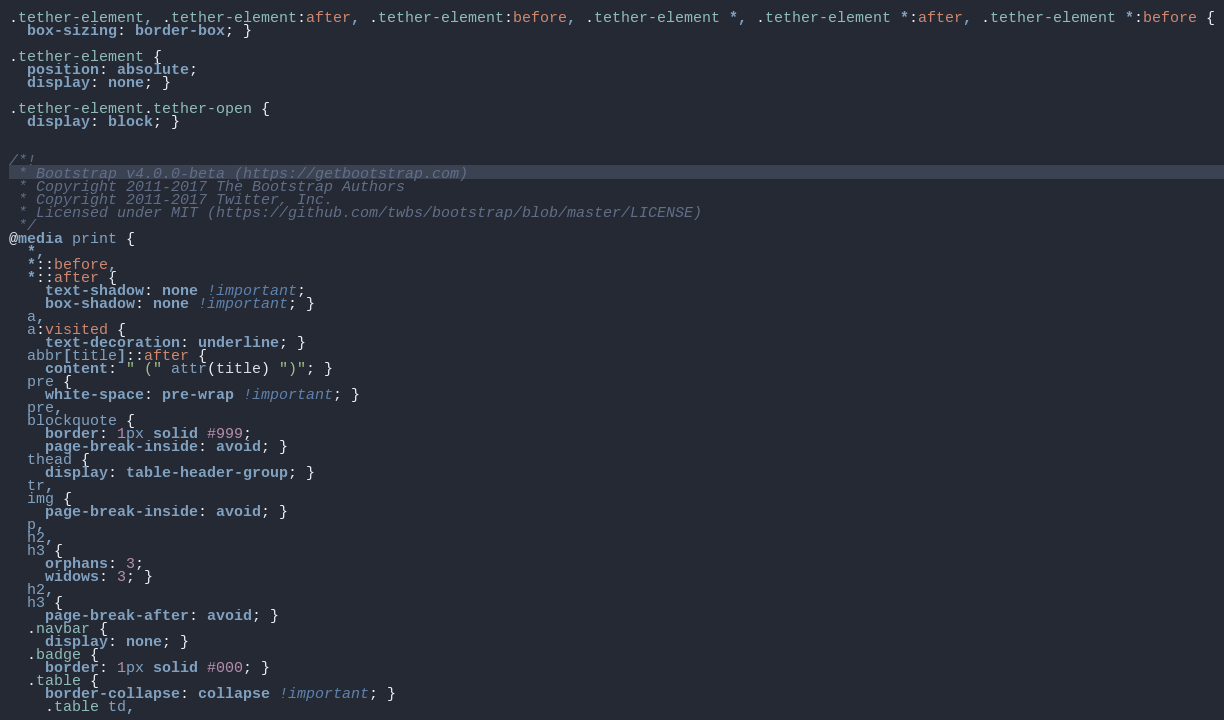<code> <loc_0><loc_0><loc_500><loc_500><_CSS_>.tether-element, .tether-element:after, .tether-element:before, .tether-element *, .tether-element *:after, .tether-element *:before {
  box-sizing: border-box; }

.tether-element {
  position: absolute;
  display: none; }

.tether-element.tether-open {
  display: block; }


/*!
 * Bootstrap v4.0.0-beta (https://getbootstrap.com)
 * Copyright 2011-2017 The Bootstrap Authors
 * Copyright 2011-2017 Twitter, Inc.
 * Licensed under MIT (https://github.com/twbs/bootstrap/blob/master/LICENSE)
 */
@media print {
  *,
  *::before,
  *::after {
    text-shadow: none !important;
    box-shadow: none !important; }
  a,
  a:visited {
    text-decoration: underline; }
  abbr[title]::after {
    content: " (" attr(title) ")"; }
  pre {
    white-space: pre-wrap !important; }
  pre,
  blockquote {
    border: 1px solid #999;
    page-break-inside: avoid; }
  thead {
    display: table-header-group; }
  tr,
  img {
    page-break-inside: avoid; }
  p,
  h2,
  h3 {
    orphans: 3;
    widows: 3; }
  h2,
  h3 {
    page-break-after: avoid; }
  .navbar {
    display: none; }
  .badge {
    border: 1px solid #000; }
  .table {
    border-collapse: collapse !important; }
    .table td,</code> 